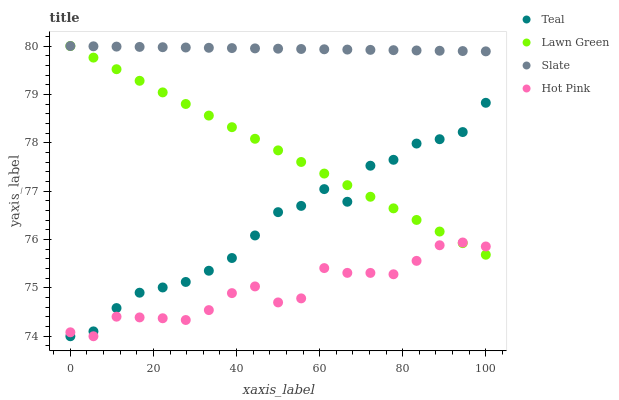Does Hot Pink have the minimum area under the curve?
Answer yes or no. Yes. Does Slate have the maximum area under the curve?
Answer yes or no. Yes. Does Slate have the minimum area under the curve?
Answer yes or no. No. Does Hot Pink have the maximum area under the curve?
Answer yes or no. No. Is Lawn Green the smoothest?
Answer yes or no. Yes. Is Teal the roughest?
Answer yes or no. Yes. Is Slate the smoothest?
Answer yes or no. No. Is Slate the roughest?
Answer yes or no. No. Does Hot Pink have the lowest value?
Answer yes or no. Yes. Does Slate have the lowest value?
Answer yes or no. No. Does Slate have the highest value?
Answer yes or no. Yes. Does Hot Pink have the highest value?
Answer yes or no. No. Is Teal less than Slate?
Answer yes or no. Yes. Is Slate greater than Hot Pink?
Answer yes or no. Yes. Does Lawn Green intersect Slate?
Answer yes or no. Yes. Is Lawn Green less than Slate?
Answer yes or no. No. Is Lawn Green greater than Slate?
Answer yes or no. No. Does Teal intersect Slate?
Answer yes or no. No. 